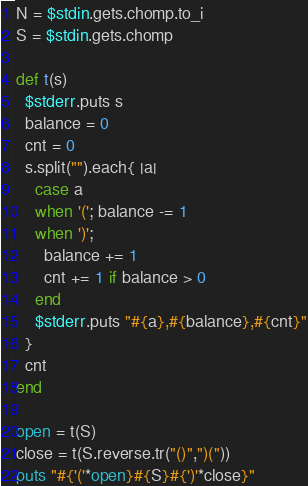Convert code to text. <code><loc_0><loc_0><loc_500><loc_500><_Ruby_>N = $stdin.gets.chomp.to_i
S = $stdin.gets.chomp

def t(s)
  $stderr.puts s
  balance = 0
  cnt = 0
  s.split("").each{ |a| 
    case a
    when '('; balance -= 1
    when ')'; 
      balance += 1
      cnt += 1 if balance > 0
    end
    $stderr.puts "#{a},#{balance},#{cnt}"
  }
  cnt
end

open = t(S)
close = t(S.reverse.tr("()",")("))
puts "#{'('*open}#{S}#{')'*close}"
</code> 